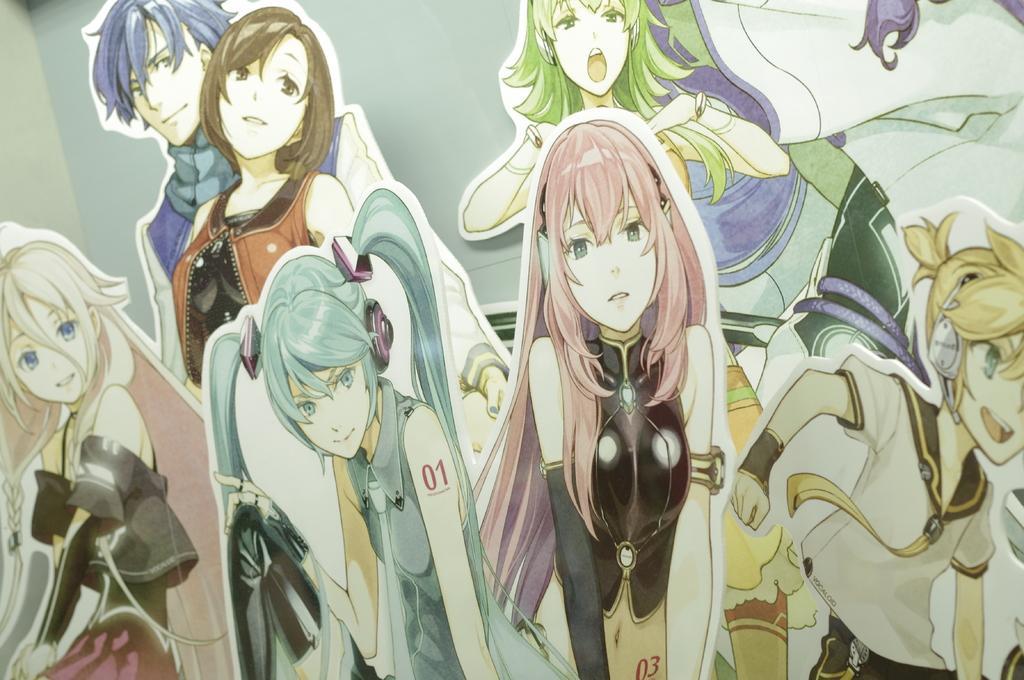Please provide a concise description of this image. This picture consists of an animated image, in which there are cartoon characters. 